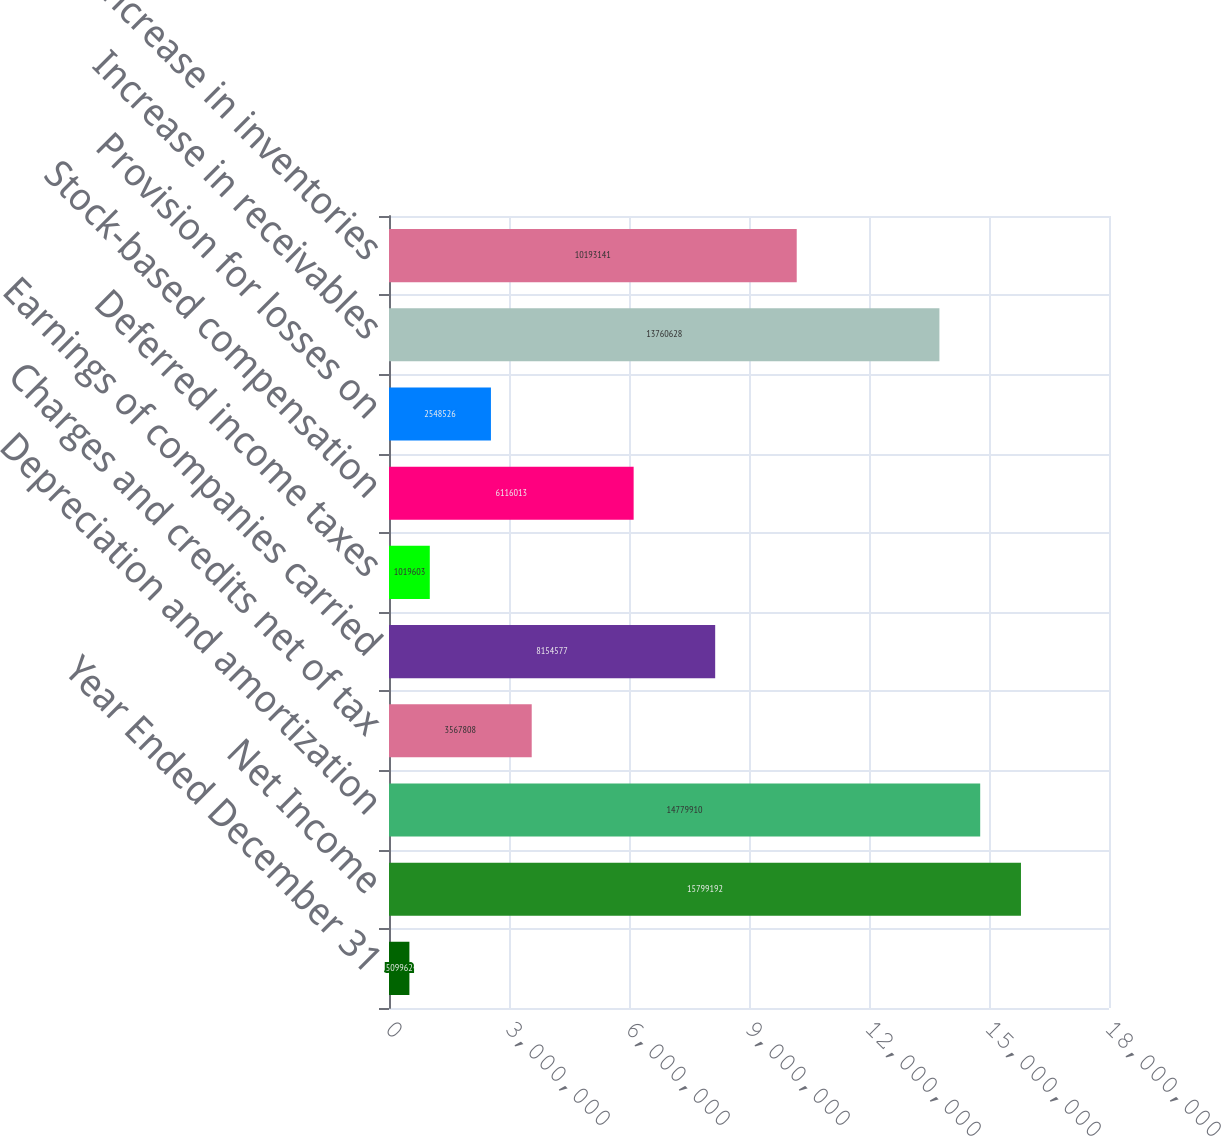Convert chart. <chart><loc_0><loc_0><loc_500><loc_500><bar_chart><fcel>Year Ended December 31<fcel>Net Income<fcel>Depreciation and amortization<fcel>Charges and credits net of tax<fcel>Earnings of companies carried<fcel>Deferred income taxes<fcel>Stock-based compensation<fcel>Provision for losses on<fcel>Increase in receivables<fcel>Increase in inventories<nl><fcel>509962<fcel>1.57992e+07<fcel>1.47799e+07<fcel>3.56781e+06<fcel>8.15458e+06<fcel>1.0196e+06<fcel>6.11601e+06<fcel>2.54853e+06<fcel>1.37606e+07<fcel>1.01931e+07<nl></chart> 